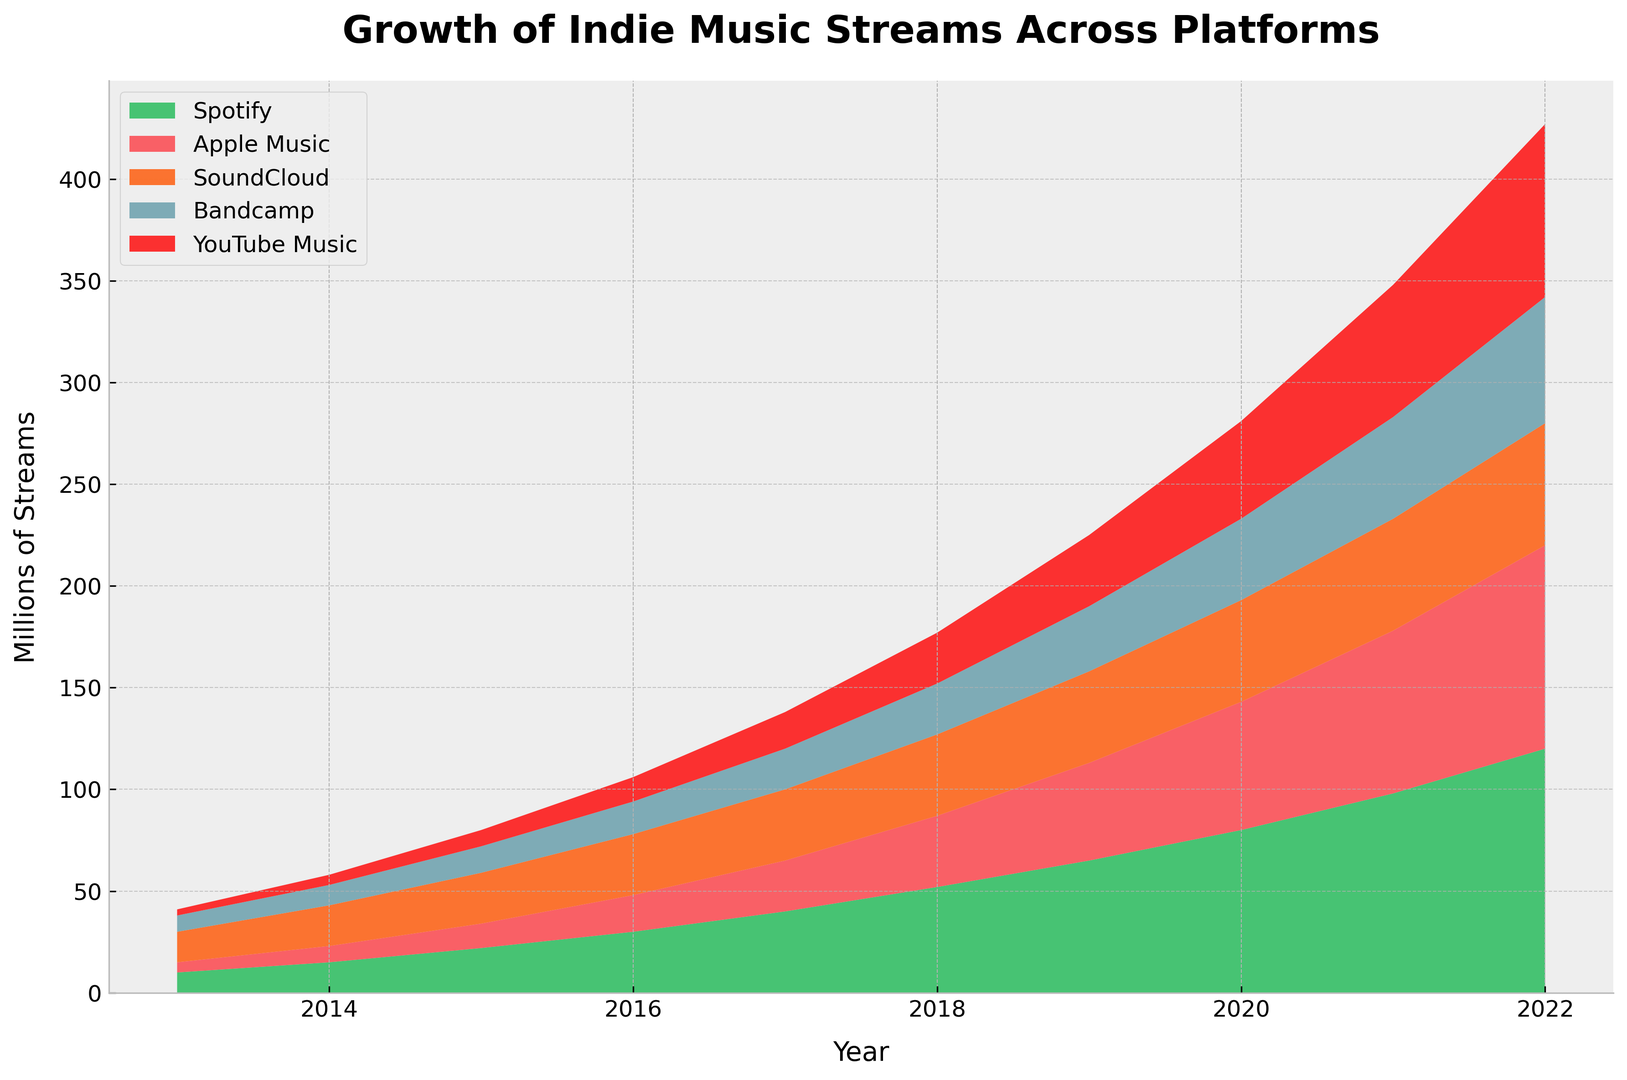What platform shows the highest increase in streams between 2019 and 2022? Compare the height of the stacked areas for each platform between the years 2019 and 2022. Spotify shows the highest increase in streams during this period.
Answer: Spotify Which platform had the lowest stream count in 2016? Look at the height of the stacked areas for each platform in the year 2016. YouTube Music has the lowest stream count.
Answer: YouTube Music How many platforms had more than 50 million streams in 2021? Examine the height of the stacked areas for each platform in 2021. Spotify, Apple Music, and YouTube Music are the platforms with more than 50 million streams. Count them.
Answer: 3 By how many millions did Bandcamp streams increase from 2014 to 2019? Calculate the difference in the height of Bandcamp's area between 2014 and 2019: 32 - 10 = 22 millions.
Answer: 22 millions What is the combined stream count for Apple Music and SoundCloud in 2018? First, sum the streams for Apple Music and SoundCloud in 2018: 35 (Apple Music) + 40 (SoundCloud) = 75 millions.
Answer: 75 millions Which year saw the highest growth in Spotify streams compared to the previous year? Check the annual growth for Spotify by subtracting the previous year's value from the current year's value. The year with the highest difference will have the highest growth. 2021 saw the highest growth: 98 (2021) - 80 (2020) = 18 millions.
Answer: 2021 In which year did all platforms combined exceed 300 million streams for the first time? Sum up the streams for all platforms year by year and identify when the sum first exceeds 300 million. In 2020, the combined streams are 80 + 63 + 50 + 40 + 48 = 281, and in 2021, the combined streams are 98 + 80 + 55 + 50 + 65 = 348.
Answer: 2021 Which platform had the steepest increase in the first three years (2013-2016)? Compare the height difference of each platform's area from 2013 to 2016. Spotify had the steepest increase from 10 to 30 million streams.
Answer: Spotify 